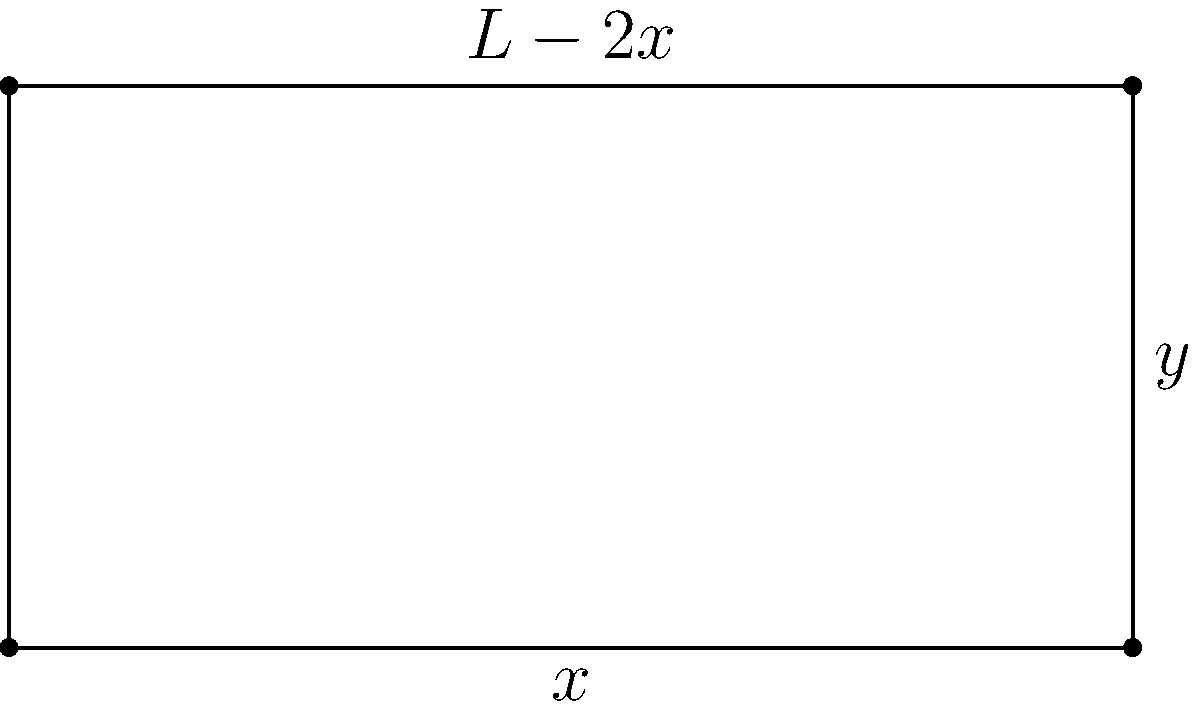A rectangular enclosure is to be constructed using a fixed amount of fencing material with a total length $L$. The width of the rectangle is denoted as $x$ and the length as $y$. Determine the dimensions that will maximize the enclosed area. How does this optimal solution compare to other possible configurations, and what insights can be drawn about the relationship between perimeter and area in this context? Let's approach this step-by-step:

1) First, we need to express the area $A$ in terms of $x$ and the total length $L$:
   
   Perimeter equation: $L = 2x + 2y$
   Solving for $y$: $y = \frac{L}{2} - x$
   
   Area equation: $A = xy = x(\frac{L}{2} - x) = \frac{L}{2}x - x^2$

2) To find the maximum area, we need to find where the derivative of $A$ with respect to $x$ is zero:
   
   $\frac{dA}{dx} = \frac{L}{2} - 2x$
   
   Set this equal to zero: $\frac{L}{2} - 2x = 0$
   
   Solve for $x$: $x = \frac{L}{4}$

3) This critical point gives us the width that maximizes the area. The length $y$ will be the same:
   
   $y = \frac{L}{2} - x = \frac{L}{2} - \frac{L}{4} = \frac{L}{4}$

4) Therefore, the optimal rectangle is a square with side length $\frac{L}{4}$.

5) To understand why this is optimal, consider:
   - If $x < \frac{L}{4}$, the rectangle is too narrow, reducing area.
   - If $x > \frac{L}{4}$, the rectangle is too wide, also reducing area.
   - The square balances these extremes, maximizing area.

6) This result demonstrates an important principle: among all rectangles with a given perimeter, the square encloses the maximum area. This illustrates the general mathematical concept that shapes with higher symmetry often optimize certain properties.

7) Reflecting on this solution reveals the delicate balance between perimeter and area in geometry. It challenges our intuition about shape and space, encouraging a deeper appreciation for mathematical optimization.
Answer: The optimal dimensions are a square with side length $\frac{L}{4}$, maximizing area by balancing length and width. 